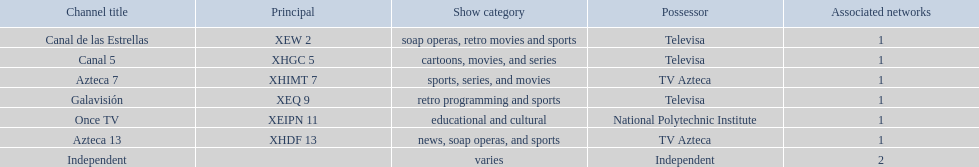How many networks do not air sports? 2. 